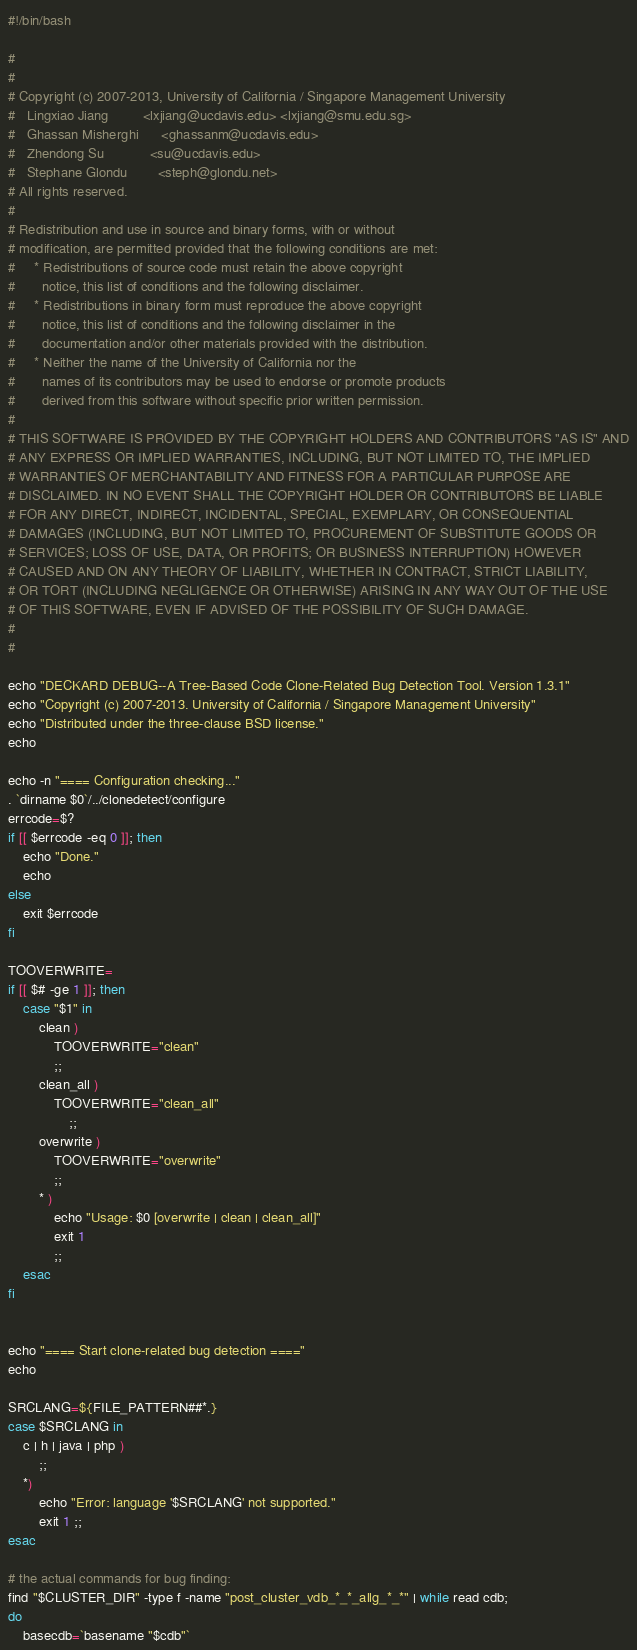<code> <loc_0><loc_0><loc_500><loc_500><_Bash_>#!/bin/bash

#
# 
# Copyright (c) 2007-2013, University of California / Singapore Management University
#   Lingxiao Jiang         <lxjiang@ucdavis.edu> <lxjiang@smu.edu.sg>
#   Ghassan Misherghi      <ghassanm@ucdavis.edu>
#   Zhendong Su            <su@ucdavis.edu>
#   Stephane Glondu        <steph@glondu.net>
# All rights reserved.
# 
# Redistribution and use in source and binary forms, with or without
# modification, are permitted provided that the following conditions are met:
#     * Redistributions of source code must retain the above copyright
#       notice, this list of conditions and the following disclaimer.
#     * Redistributions in binary form must reproduce the above copyright
#       notice, this list of conditions and the following disclaimer in the
#       documentation and/or other materials provided with the distribution.
#     * Neither the name of the University of California nor the
#       names of its contributors may be used to endorse or promote products
#       derived from this software without specific prior written permission.
# 
# THIS SOFTWARE IS PROVIDED BY THE COPYRIGHT HOLDERS AND CONTRIBUTORS "AS IS" AND
# ANY EXPRESS OR IMPLIED WARRANTIES, INCLUDING, BUT NOT LIMITED TO, THE IMPLIED
# WARRANTIES OF MERCHANTABILITY AND FITNESS FOR A PARTICULAR PURPOSE ARE
# DISCLAIMED. IN NO EVENT SHALL THE COPYRIGHT HOLDER OR CONTRIBUTORS BE LIABLE
# FOR ANY DIRECT, INDIRECT, INCIDENTAL, SPECIAL, EXEMPLARY, OR CONSEQUENTIAL
# DAMAGES (INCLUDING, BUT NOT LIMITED TO, PROCUREMENT OF SUBSTITUTE GOODS OR
# SERVICES; LOSS OF USE, DATA, OR PROFITS; OR BUSINESS INTERRUPTION) HOWEVER
# CAUSED AND ON ANY THEORY OF LIABILITY, WHETHER IN CONTRACT, STRICT LIABILITY,
# OR TORT (INCLUDING NEGLIGENCE OR OTHERWISE) ARISING IN ANY WAY OUT OF THE USE
# OF THIS SOFTWARE, EVEN IF ADVISED OF THE POSSIBILITY OF SUCH DAMAGE.
# 
#

echo "DECKARD DEBUG--A Tree-Based Code Clone-Related Bug Detection Tool. Version 1.3.1"
echo "Copyright (c) 2007-2013. University of California / Singapore Management University"
echo "Distributed under the three-clause BSD license."
echo

echo -n "==== Configuration checking..."
. `dirname $0`/../clonedetect/configure
errcode=$?
if [[ $errcode -eq 0 ]]; then
	echo "Done."
	echo
else
	exit $errcode
fi

TOOVERWRITE=
if [[ $# -ge 1 ]]; then
	case "$1" in
		clean )
			TOOVERWRITE="clean"
			;;
		clean_all )
			TOOVERWRITE="clean_all"
		       	;;
		overwrite )
			TOOVERWRITE="overwrite"
			;;
		* )
			echo "Usage: $0 [overwrite | clean | clean_all]"
			exit 1
			;;
	esac
fi


echo "==== Start clone-related bug detection ====" 
echo

SRCLANG=${FILE_PATTERN##*.}
case $SRCLANG in
	c | h | java | php )
		;;
	*)
		echo "Error: language '$SRCLANG' not supported."
		exit 1 ;;
esac

# the actual commands for bug finding:
find "$CLUSTER_DIR" -type f -name "post_cluster_vdb_*_*_allg_*_*" | while read cdb;
do
	basecdb=`basename "$cdb"`</code> 